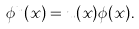<formula> <loc_0><loc_0><loc_500><loc_500>\phi ^ { u } ( x ) = u ( x ) \phi ( x ) .</formula> 